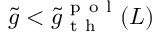Convert formula to latex. <formula><loc_0><loc_0><loc_500><loc_500>\tilde { g } < \tilde { g } _ { t h } ^ { p o l } ( L )</formula> 